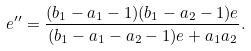<formula> <loc_0><loc_0><loc_500><loc_500>e ^ { \prime \prime } = \frac { ( b _ { 1 } - a _ { 1 } - 1 ) ( b _ { 1 } - a _ { 2 } - 1 ) e } { ( b _ { 1 } - a _ { 1 } - a _ { 2 } - 1 ) e + a _ { 1 } a _ { 2 } } .</formula> 